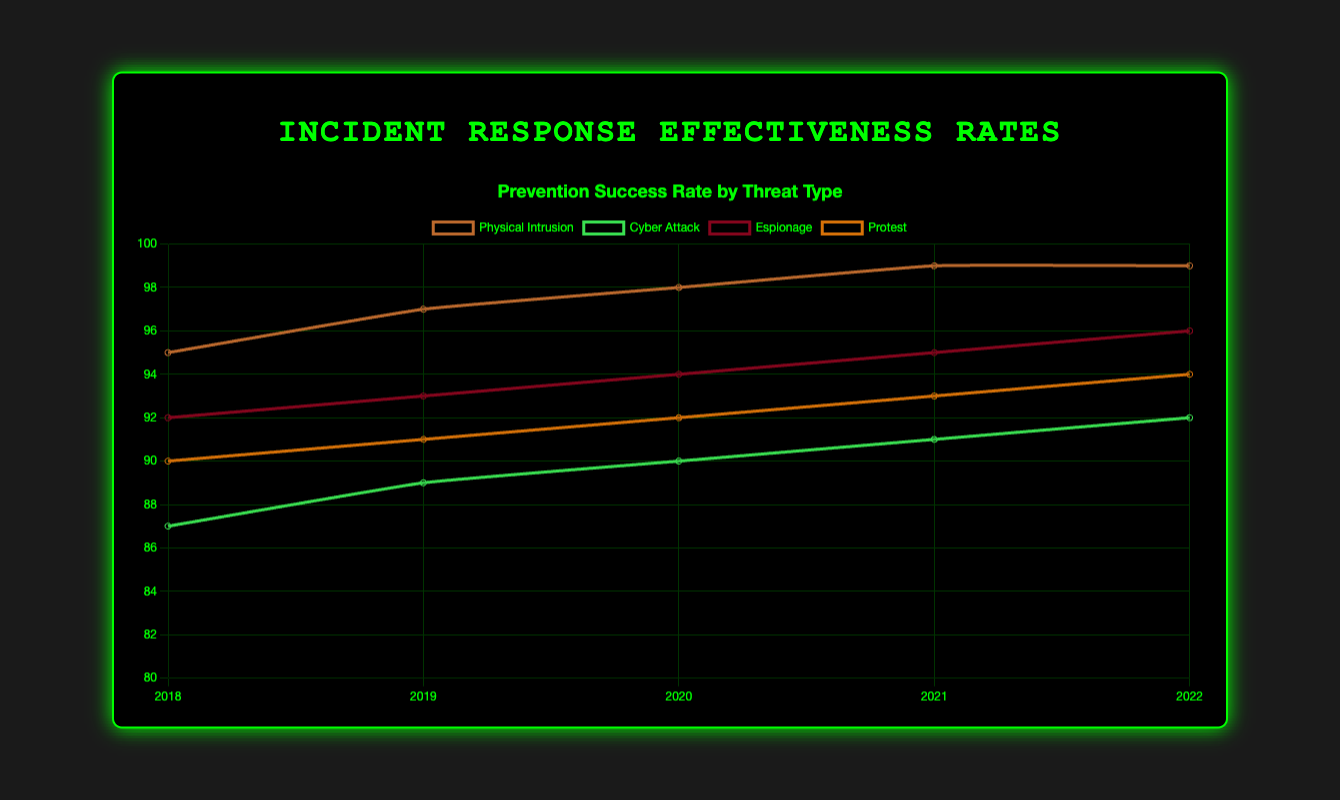Which threat type had the highest prevention success rate in 2022? Examine the prevention success rate for each threat type in 2022. Physical Intrusion and Espionage both show a prevention success rate of 99.
Answer: Physical Intrusion and Espionage How did the prevention success rate of Cyber Attack change from 2018 to 2022? Look at the prevention success rates for Cyber Attack from 2018 to 2022. In 2018 it was 87, and it increased each year to reach 92 in 2022.
Answer: Increased from 87 to 92 Among the different threat types, which one had the smallest range of prevention success rates between 2018 and 2022? Calculate the range (max - min) of prevention success rates for each threat type. Physical Intrusion ranges from 95 to 99 (range: 4), Cyber Attack from 87 to 92 (range: 5), Espionage from 92 to 96 (range: 4), and Protest from 90 to 94 (range: 4).
Answer: Physical Intrusion, Espionage, and Protest In which year did Physical Intrusion achieve its highest prevention success rate? Look at the prevention success rate for Physical Intrusion across all years (2018-2022). The highest rate was 99, achieved in 2021 and 2022.
Answer: 2021 and 2022 Compare the prevention success rates of Espionage and Cyber Attack in 2020. Which one was higher? Check the prevention success rates for Espionage and Cyber Attack in 2020. Espionage had a success rate of 94, and Cyber Attack had 90.
Answer: Espionage Which threat type saw the most consistent increase in prevention success rate from 2018 to 2022? Analyze the prevention success rates for each threat type from 2018 to 2022. Only Physical Intrusion shows a consistent year-on-year increase.
Answer: Physical Intrusion What is the average response time across all threat types in 2019? Add up the response time for each threat type in 2019 and divide by the number of threat types (11 + 38 + 23 + 14) / 4.
Answer: 21.5 minutes How did the response time for Protests change from 2018 to 2022? Look at the response time for Protests in each year. It decreased from 15 minutes in 2018 to 11 minutes in 2022.
Answer: Decreased from 15 to 11 minutes Which year's data shows the highest average prevention success rate across all threat types? Calculate the average prevention success rate for each year (sum of rates / number of threat types). For each year: 2018 = 91, 2019 = 92.5, 2020 = 93.5, 2021 = 94.5, 2022 = 95.25.
Answer: 2022 